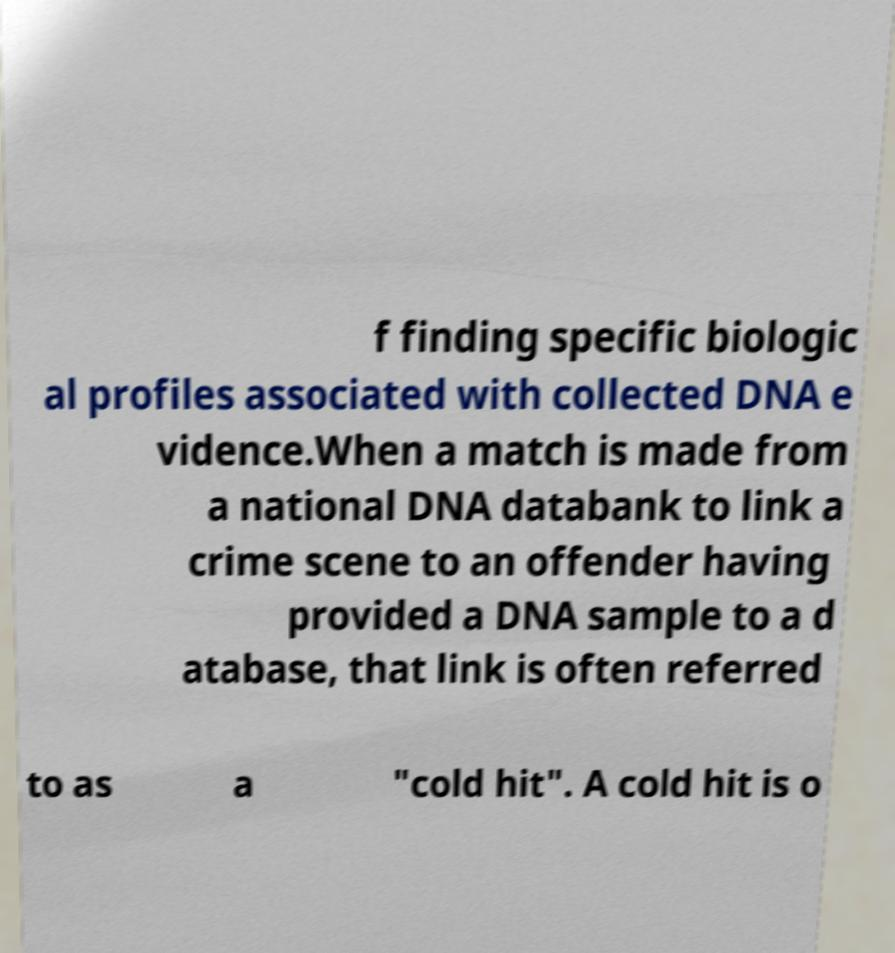Could you assist in decoding the text presented in this image and type it out clearly? f finding specific biologic al profiles associated with collected DNA e vidence.When a match is made from a national DNA databank to link a crime scene to an offender having provided a DNA sample to a d atabase, that link is often referred to as a "cold hit". A cold hit is o 